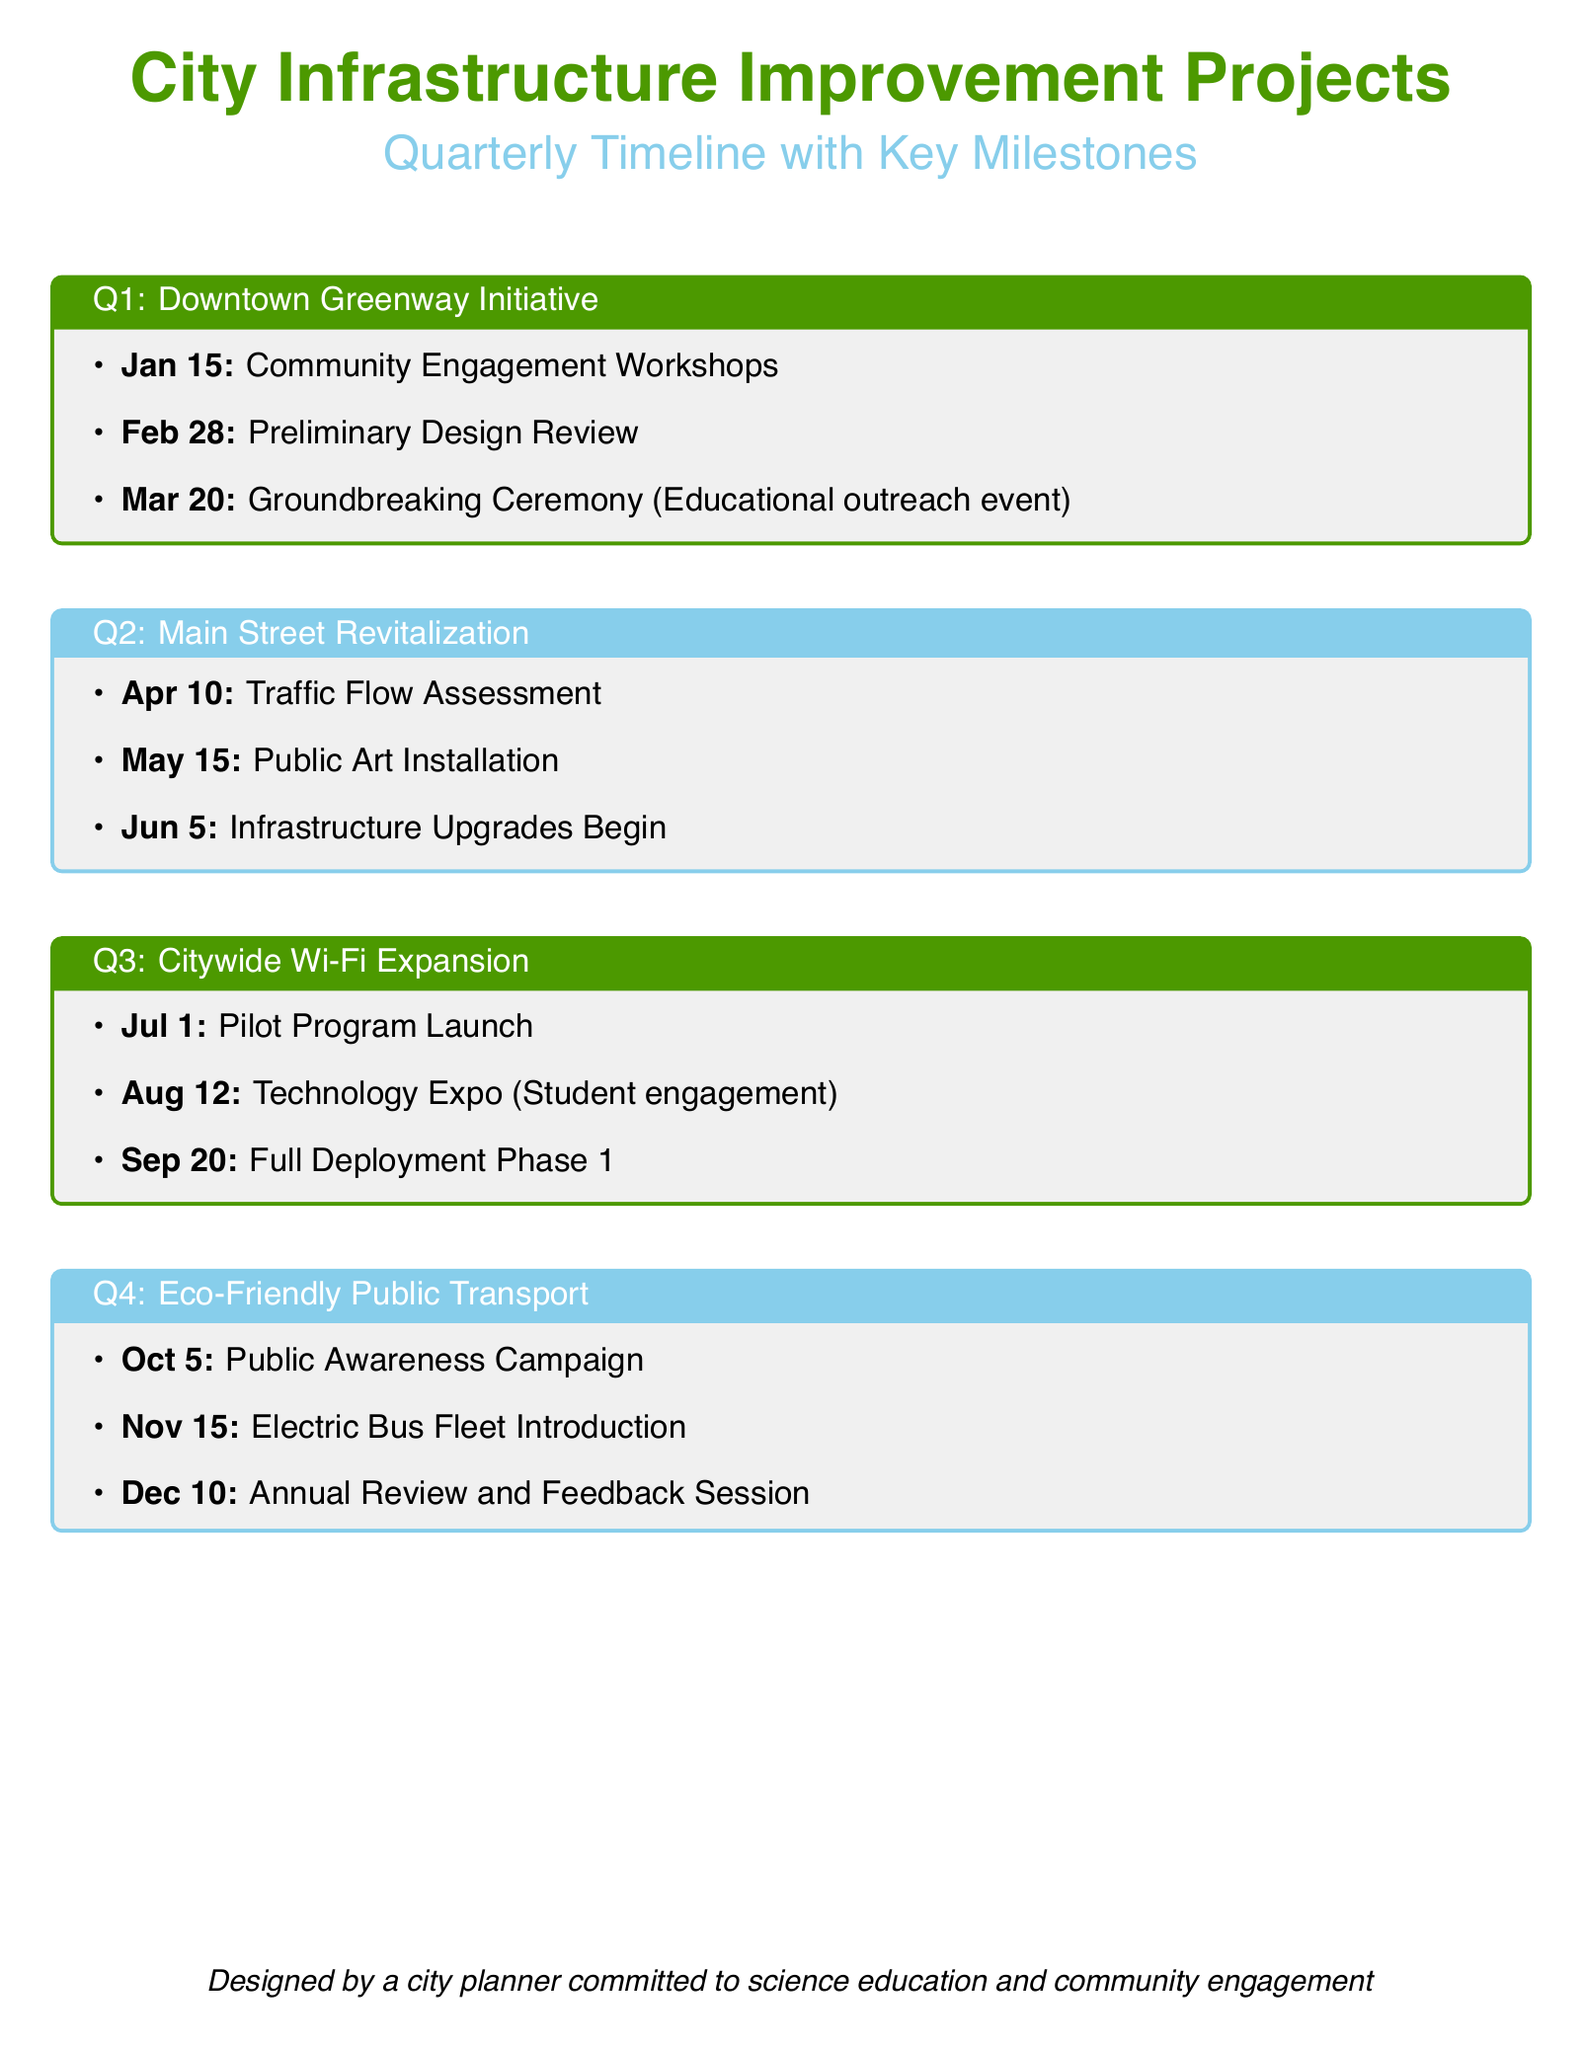What is the first key milestone in Q1? The first key milestone listed under Q1 is the "Community Engagement Workshops" on January 15.
Answer: Community Engagement Workshops What date is the Traffic Flow Assessment scheduled for in Q2? The document specifies that the Traffic Flow Assessment is scheduled for April 10 in Q2.
Answer: April 10 Which project begins in June? The document indicates that infrastructure upgrades begin in June under the Main Street Revitalization project.
Answer: Main Street Revitalization When does the Eco-Friendly Public Transport campaign start? According to the document, the Public Awareness Campaign for Eco-Friendly Public Transport starts on October 5.
Answer: October 5 What type of event is scheduled on March 20? The document states that there is a Groundbreaking Ceremony, which is described as an educational outreach event on March 20.
Answer: Groundbreaking Ceremony What is a key aspect of the Q3 project? The document highlights that the Q3 project includes a technology expo aimed at student engagement on August 12.
Answer: Student engagement How many main projects are listed in the calendar? The document contains four projects outlined in the quarterly timeline.
Answer: Four What is the last key milestone of the calendar? The last key milestone mentioned in the document is the "Annual Review and Feedback Session" on December 10.
Answer: Annual Review and Feedback Session 